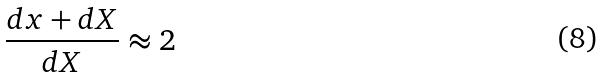<formula> <loc_0><loc_0><loc_500><loc_500>\frac { d x + d X } { d X } \approx 2</formula> 